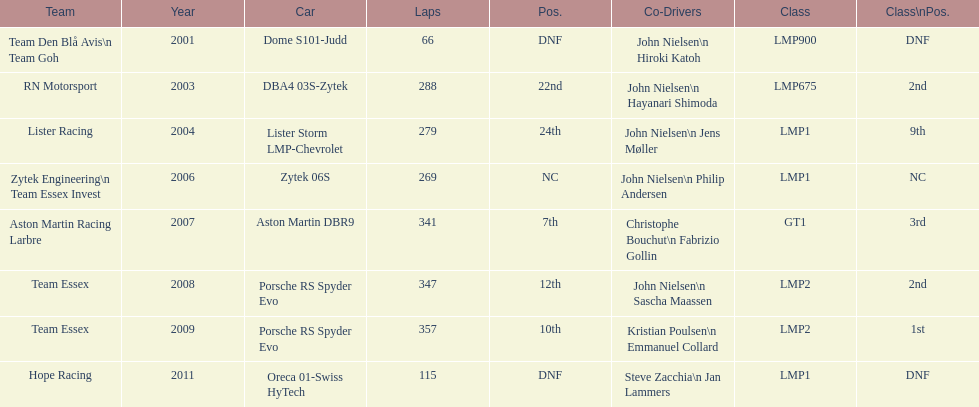In 2008 and what other year was casper elgaard on team essex for the 24 hours of le mans? 2009. 